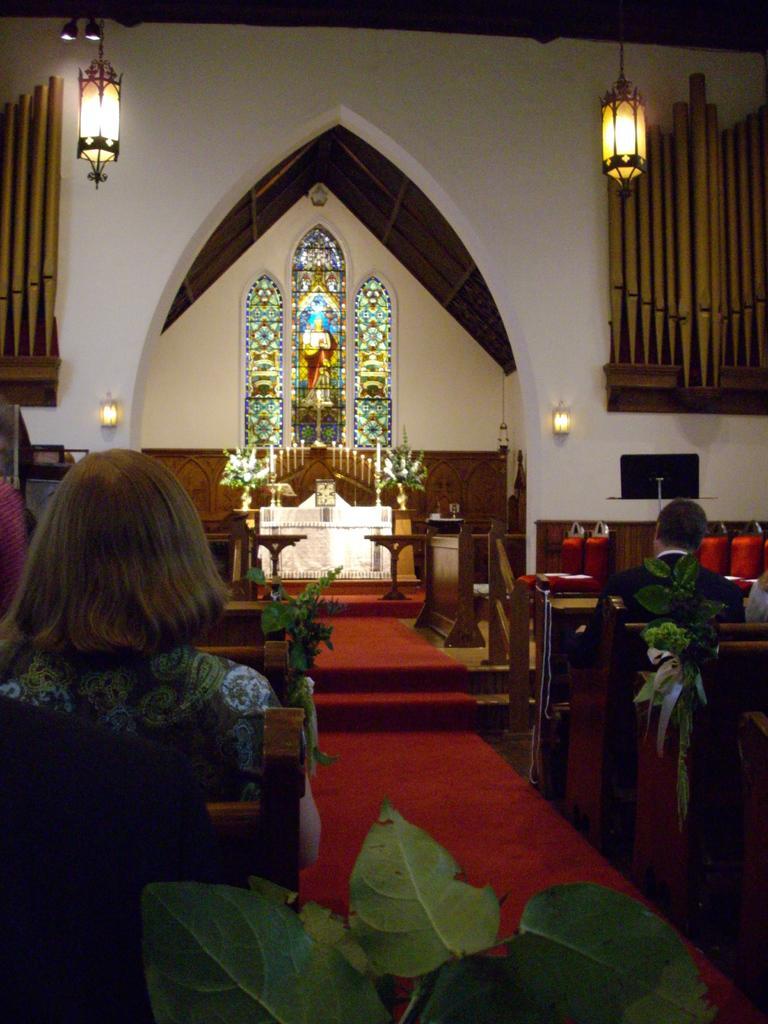In one or two sentences, can you explain what this image depicts? In this image there are two people sitting on the benches inside a church, around them there are plants, lamps on the walls, in front of them there are flower bouquets and cross on the table, behind the table there are candles and there is a glass window with painting on the wall. 